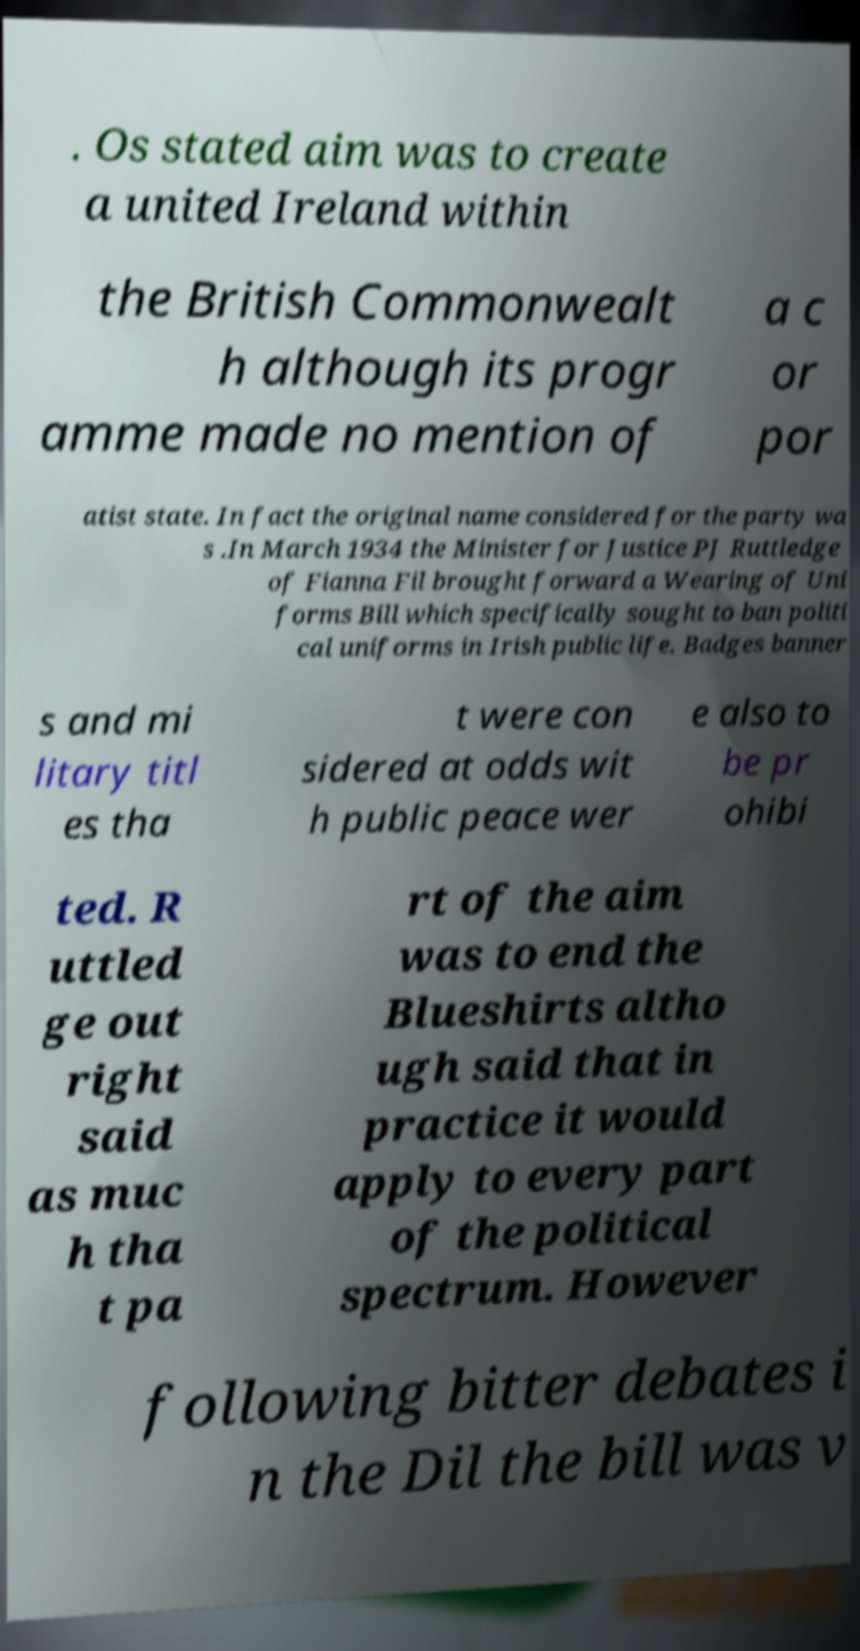What messages or text are displayed in this image? I need them in a readable, typed format. . Os stated aim was to create a united Ireland within the British Commonwealt h although its progr amme made no mention of a c or por atist state. In fact the original name considered for the party wa s .In March 1934 the Minister for Justice PJ Ruttledge of Fianna Fil brought forward a Wearing of Uni forms Bill which specifically sought to ban politi cal uniforms in Irish public life. Badges banner s and mi litary titl es tha t were con sidered at odds wit h public peace wer e also to be pr ohibi ted. R uttled ge out right said as muc h tha t pa rt of the aim was to end the Blueshirts altho ugh said that in practice it would apply to every part of the political spectrum. However following bitter debates i n the Dil the bill was v 